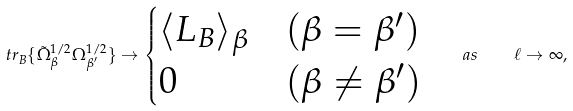<formula> <loc_0><loc_0><loc_500><loc_500>\ t r _ { B } \{ \tilde { \Omega } _ { \beta } ^ { 1 / 2 } \Omega _ { \beta ^ { \prime } } ^ { 1 / 2 } \} \to \begin{cases} \langle L _ { B } \rangle _ { \beta } & ( \beta = \beta ^ { \prime } ) \\ 0 & ( \beta \neq \beta ^ { \prime } ) \end{cases} \quad a s \quad \ell \to \infty ,</formula> 